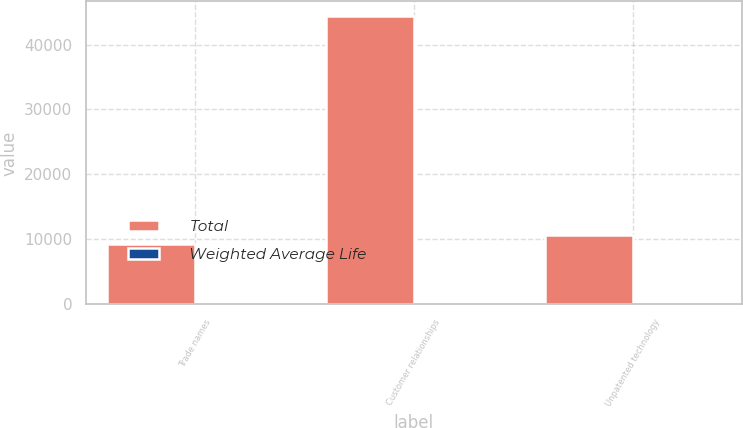<chart> <loc_0><loc_0><loc_500><loc_500><stacked_bar_chart><ecel><fcel>Trade names<fcel>Customer relationships<fcel>Unpatented technology<nl><fcel>Total<fcel>9247<fcel>44401<fcel>10711<nl><fcel>Weighted Average Life<fcel>15<fcel>12<fcel>8<nl></chart> 